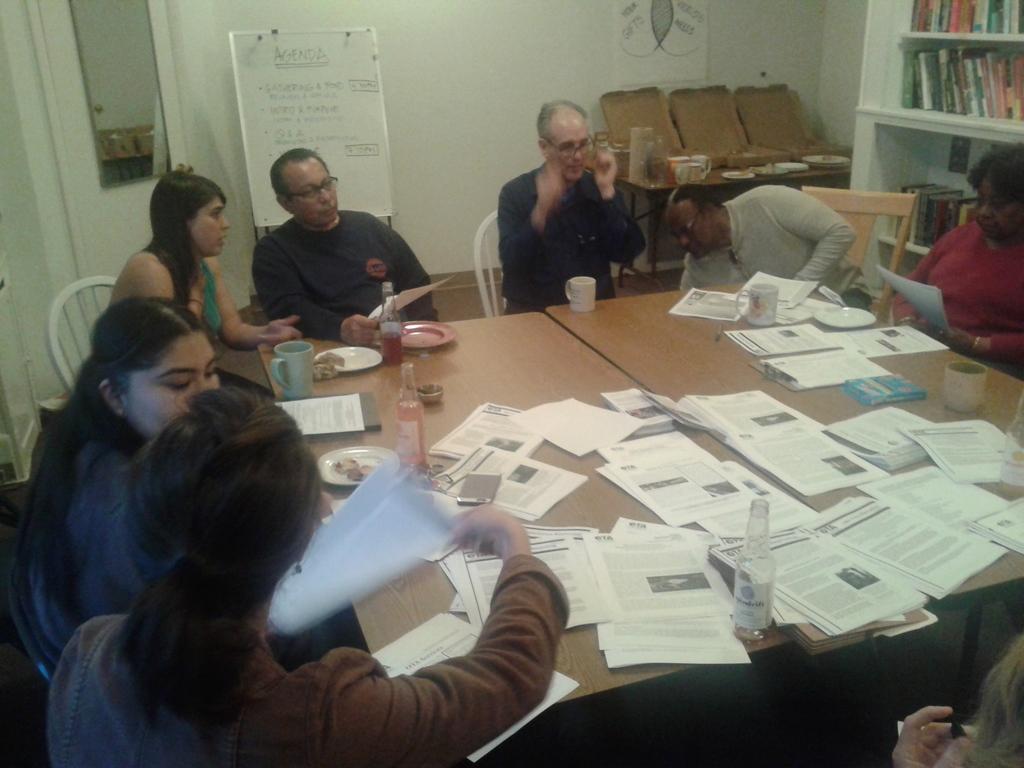Describe this image in one or two sentences. In this image people are sitting on the chairs. In front of them there is a table. On top of the table there are plates, bottles, mugs, papers. At the right side of the image there are shelves with the books. At the back side there is a wall. In front of the wall there is a board. Beside the board there is a mirror. Beside the shelf's there is an another table. On top of the table there are plates and other few objects. 